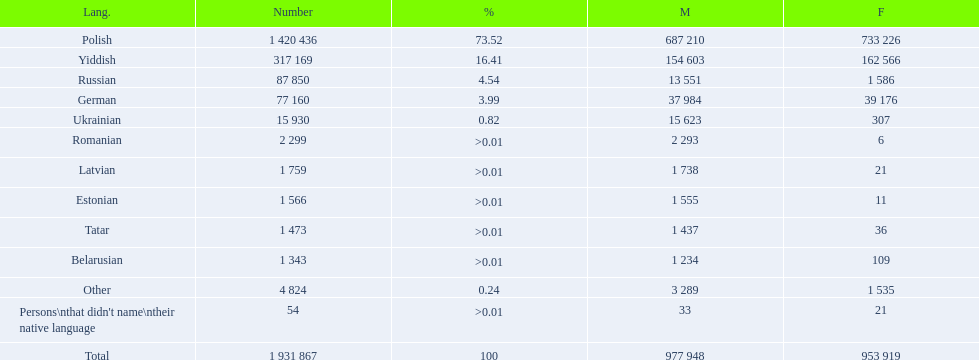What languages are spoken in the warsaw governorate? Polish, Yiddish, Russian, German, Ukrainian, Romanian, Latvian, Estonian, Tatar, Belarusian, Other, Persons\nthat didn't name\ntheir native language. What is the number for russian? 87 850. On this list what is the next lowest number? 77 160. Which language has a number of 77160 speakers? German. 